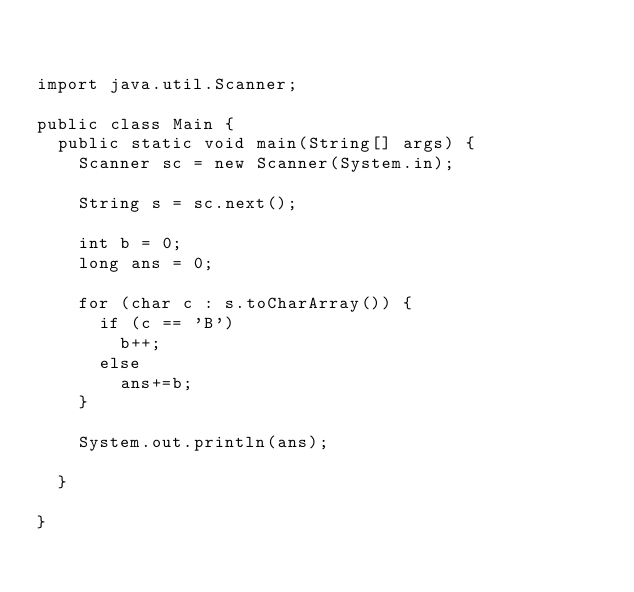Convert code to text. <code><loc_0><loc_0><loc_500><loc_500><_Java_>

import java.util.Scanner;

public class Main {
	public static void main(String[] args) {
		Scanner sc = new Scanner(System.in);

		String s = sc.next();

		int b = 0;
		long ans = 0;

		for (char c : s.toCharArray()) {
			if (c == 'B')
				b++;
			else
				ans+=b;
		}

		System.out.println(ans);

	}

}
</code> 